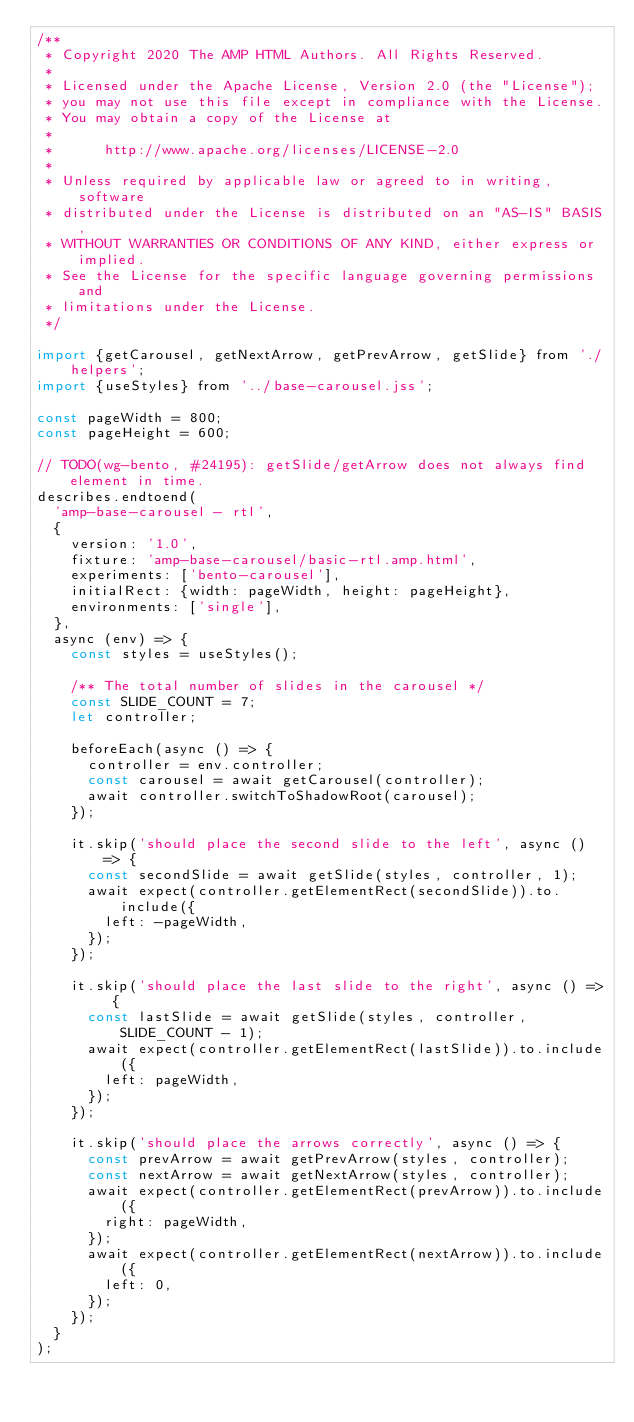<code> <loc_0><loc_0><loc_500><loc_500><_JavaScript_>/**
 * Copyright 2020 The AMP HTML Authors. All Rights Reserved.
 *
 * Licensed under the Apache License, Version 2.0 (the "License");
 * you may not use this file except in compliance with the License.
 * You may obtain a copy of the License at
 *
 *      http://www.apache.org/licenses/LICENSE-2.0
 *
 * Unless required by applicable law or agreed to in writing, software
 * distributed under the License is distributed on an "AS-IS" BASIS,
 * WITHOUT WARRANTIES OR CONDITIONS OF ANY KIND, either express or implied.
 * See the License for the specific language governing permissions and
 * limitations under the License.
 */

import {getCarousel, getNextArrow, getPrevArrow, getSlide} from './helpers';
import {useStyles} from '../base-carousel.jss';

const pageWidth = 800;
const pageHeight = 600;

// TODO(wg-bento, #24195): getSlide/getArrow does not always find element in time.
describes.endtoend(
  'amp-base-carousel - rtl',
  {
    version: '1.0',
    fixture: 'amp-base-carousel/basic-rtl.amp.html',
    experiments: ['bento-carousel'],
    initialRect: {width: pageWidth, height: pageHeight},
    environments: ['single'],
  },
  async (env) => {
    const styles = useStyles();

    /** The total number of slides in the carousel */
    const SLIDE_COUNT = 7;
    let controller;

    beforeEach(async () => {
      controller = env.controller;
      const carousel = await getCarousel(controller);
      await controller.switchToShadowRoot(carousel);
    });

    it.skip('should place the second slide to the left', async () => {
      const secondSlide = await getSlide(styles, controller, 1);
      await expect(controller.getElementRect(secondSlide)).to.include({
        left: -pageWidth,
      });
    });

    it.skip('should place the last slide to the right', async () => {
      const lastSlide = await getSlide(styles, controller, SLIDE_COUNT - 1);
      await expect(controller.getElementRect(lastSlide)).to.include({
        left: pageWidth,
      });
    });

    it.skip('should place the arrows correctly', async () => {
      const prevArrow = await getPrevArrow(styles, controller);
      const nextArrow = await getNextArrow(styles, controller);
      await expect(controller.getElementRect(prevArrow)).to.include({
        right: pageWidth,
      });
      await expect(controller.getElementRect(nextArrow)).to.include({
        left: 0,
      });
    });
  }
);
</code> 